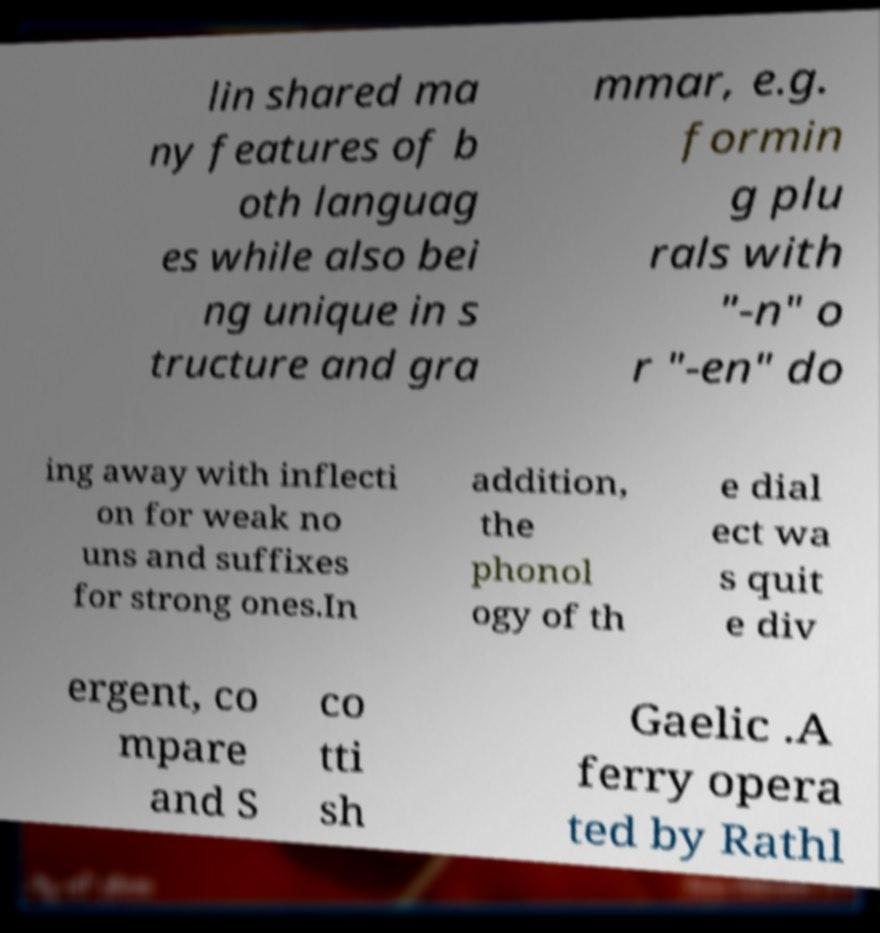Can you read and provide the text displayed in the image?This photo seems to have some interesting text. Can you extract and type it out for me? lin shared ma ny features of b oth languag es while also bei ng unique in s tructure and gra mmar, e.g. formin g plu rals with "-n" o r "-en" do ing away with inflecti on for weak no uns and suffixes for strong ones.In addition, the phonol ogy of th e dial ect wa s quit e div ergent, co mpare and S co tti sh Gaelic .A ferry opera ted by Rathl 